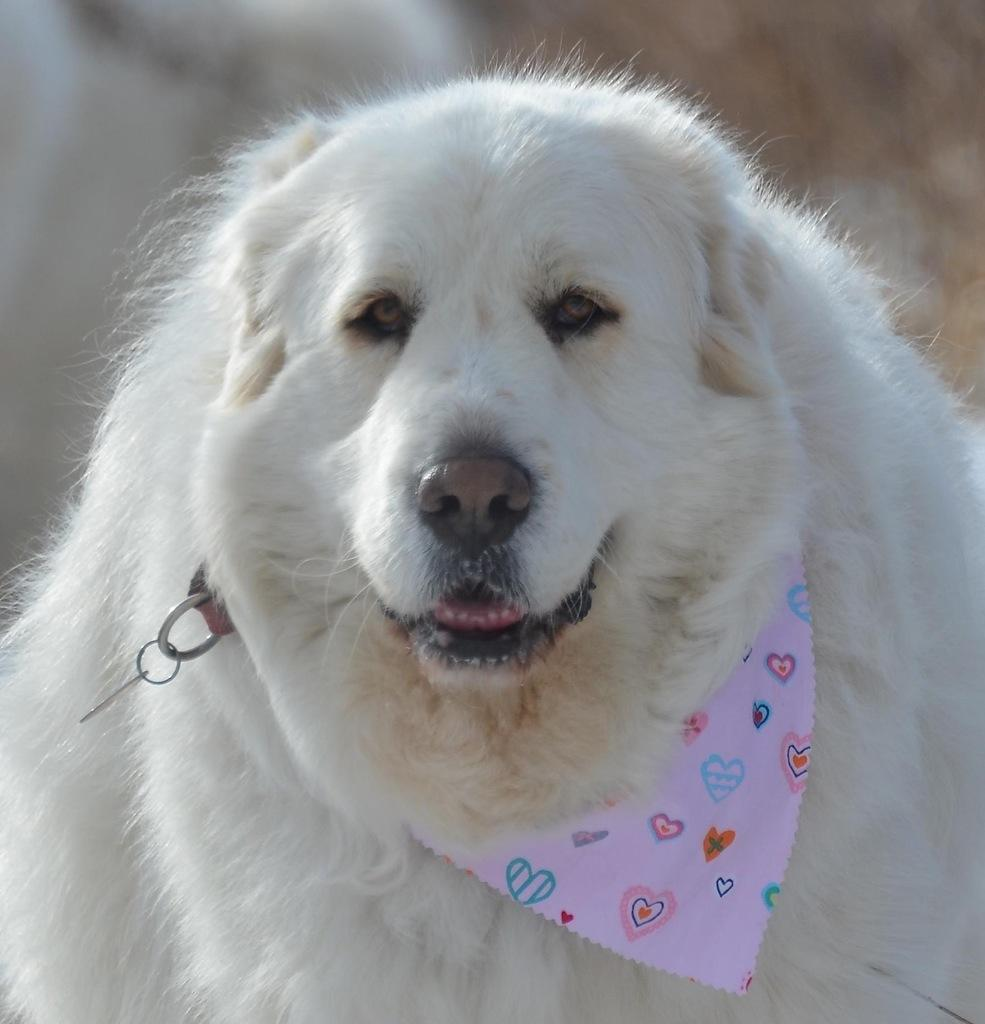What is the main subject of the image? There is an animal in the center of the image. What hobbies does the animal have, as depicted in the image? There is no information about the animal's hobbies in the image. 